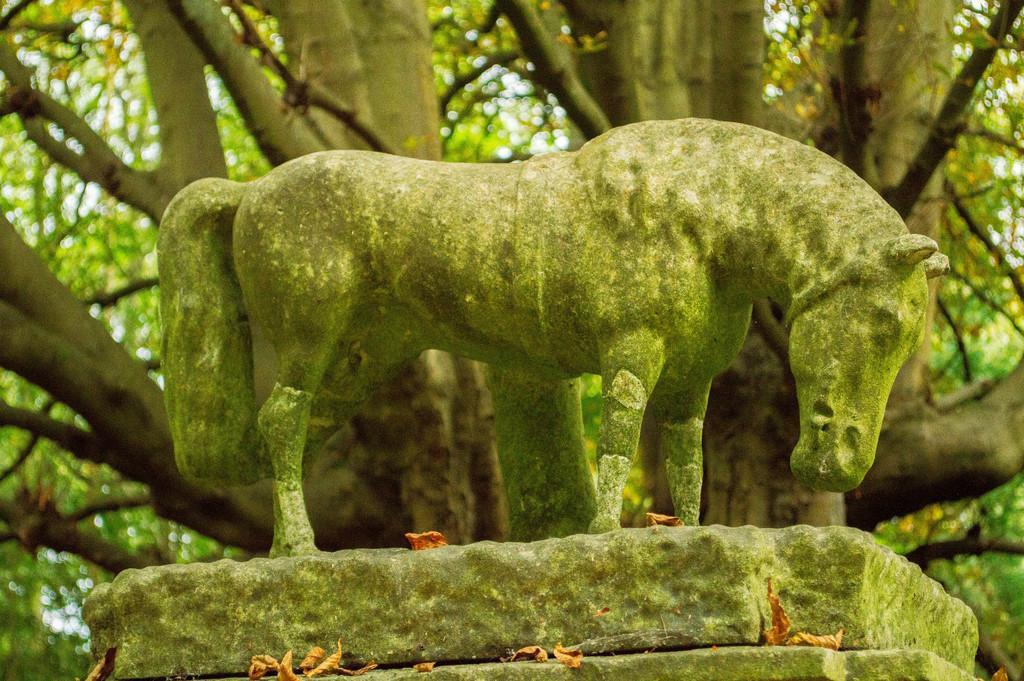Could you give a brief overview of what you see in this image? In this image we can see statue, pedestal, shredded leaves, trees and sky. 